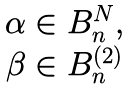<formula> <loc_0><loc_0><loc_500><loc_500>\begin{matrix} \alpha \in B _ { n } ^ { N } , \\ \beta \in B _ { n } ^ { ( 2 ) } \end{matrix}</formula> 